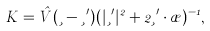Convert formula to latex. <formula><loc_0><loc_0><loc_500><loc_500>K = \hat { V } ( \xi - \xi ^ { \prime } ) ( | \xi ^ { \prime } | ^ { 2 } + 2 \xi ^ { \prime } \cdot \rho ) ^ { - 1 } ,</formula> 